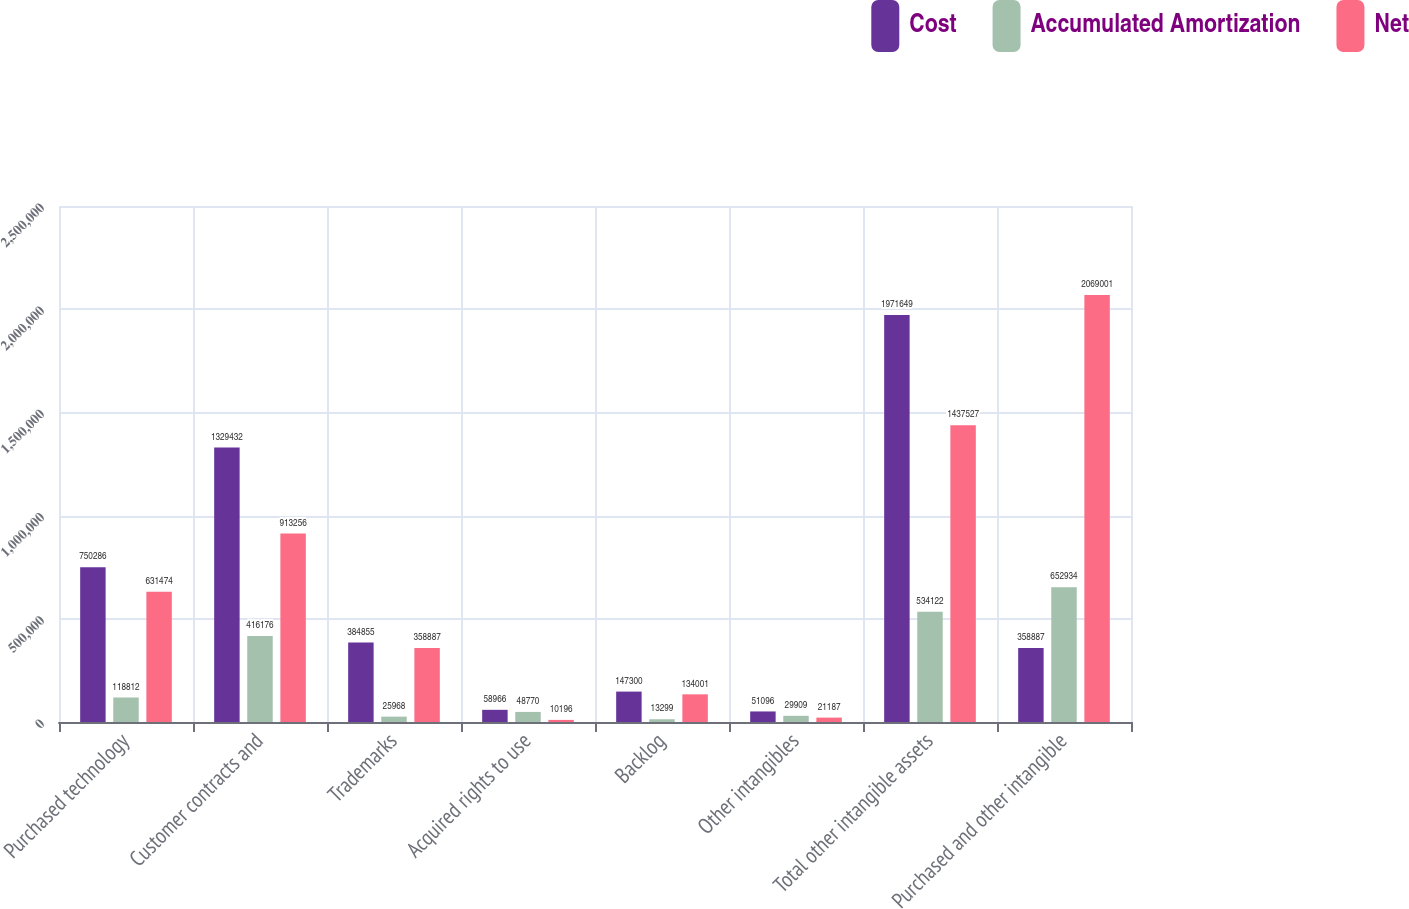Convert chart to OTSL. <chart><loc_0><loc_0><loc_500><loc_500><stacked_bar_chart><ecel><fcel>Purchased technology<fcel>Customer contracts and<fcel>Trademarks<fcel>Acquired rights to use<fcel>Backlog<fcel>Other intangibles<fcel>Total other intangible assets<fcel>Purchased and other intangible<nl><fcel>Cost<fcel>750286<fcel>1.32943e+06<fcel>384855<fcel>58966<fcel>147300<fcel>51096<fcel>1.97165e+06<fcel>358887<nl><fcel>Accumulated Amortization<fcel>118812<fcel>416176<fcel>25968<fcel>48770<fcel>13299<fcel>29909<fcel>534122<fcel>652934<nl><fcel>Net<fcel>631474<fcel>913256<fcel>358887<fcel>10196<fcel>134001<fcel>21187<fcel>1.43753e+06<fcel>2.069e+06<nl></chart> 